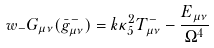<formula> <loc_0><loc_0><loc_500><loc_500>w _ { - } G _ { \mu \nu } ( \bar { g } _ { \mu \nu } ^ { - } ) = k \kappa _ { 5 } ^ { 2 } T _ { \mu \nu } ^ { - } - \frac { E _ { \mu \nu } } { \Omega ^ { 4 } }</formula> 